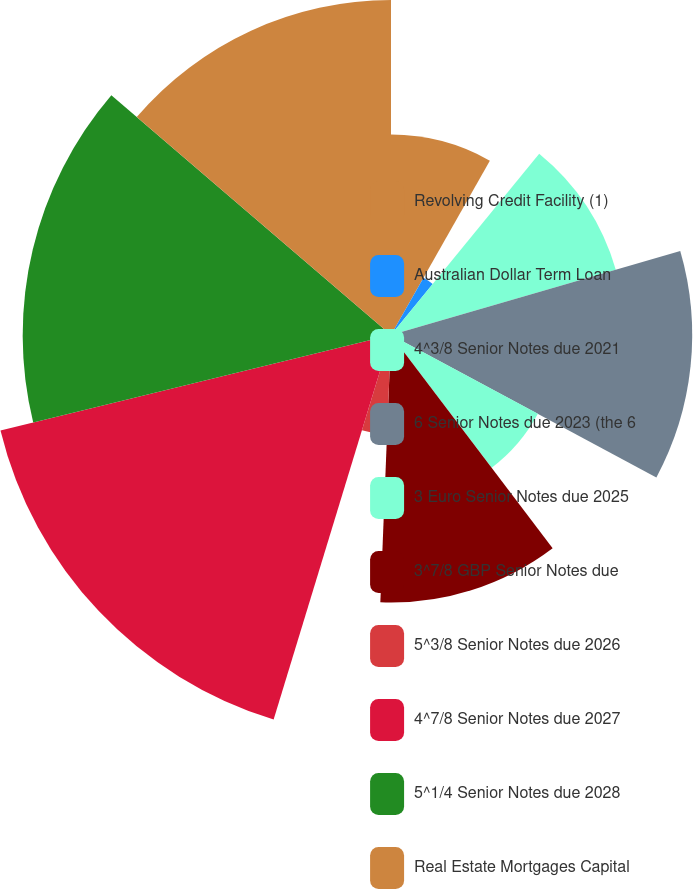Convert chart to OTSL. <chart><loc_0><loc_0><loc_500><loc_500><pie_chart><fcel>Revolving Credit Facility (1)<fcel>Australian Dollar Term Loan<fcel>4^3/8 Senior Notes due 2021<fcel>6 Senior Notes due 2023 (the 6<fcel>3 Euro Senior Notes due 2025<fcel>3^7/8 GBP Senior Notes due<fcel>5^3/8 Senior Notes due 2026<fcel>4^7/8 Senior Notes due 2027<fcel>5^1/4 Senior Notes due 2028<fcel>Real Estate Mortgages Capital<nl><fcel>8.21%<fcel>2.7%<fcel>9.59%<fcel>12.34%<fcel>6.83%<fcel>10.96%<fcel>4.08%<fcel>16.47%<fcel>15.09%<fcel>13.72%<nl></chart> 